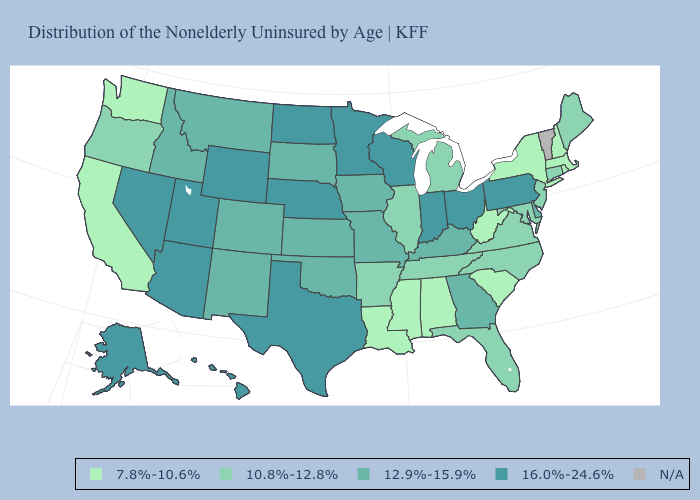Is the legend a continuous bar?
Keep it brief. No. Name the states that have a value in the range 10.8%-12.8%?
Answer briefly. Arkansas, Connecticut, Florida, Illinois, Maine, Maryland, Michigan, New Jersey, North Carolina, Oregon, Tennessee, Virginia. Name the states that have a value in the range 7.8%-10.6%?
Write a very short answer. Alabama, California, Louisiana, Massachusetts, Mississippi, New Hampshire, New York, Rhode Island, South Carolina, Washington, West Virginia. Does Virginia have the lowest value in the South?
Be succinct. No. Name the states that have a value in the range 7.8%-10.6%?
Short answer required. Alabama, California, Louisiana, Massachusetts, Mississippi, New Hampshire, New York, Rhode Island, South Carolina, Washington, West Virginia. How many symbols are there in the legend?
Concise answer only. 5. Name the states that have a value in the range 12.9%-15.9%?
Be succinct. Colorado, Delaware, Georgia, Idaho, Iowa, Kansas, Kentucky, Missouri, Montana, New Mexico, Oklahoma, South Dakota. Which states hav the highest value in the West?
Give a very brief answer. Alaska, Arizona, Hawaii, Nevada, Utah, Wyoming. What is the value of California?
Write a very short answer. 7.8%-10.6%. Does Montana have the lowest value in the West?
Write a very short answer. No. Does Texas have the highest value in the South?
Be succinct. Yes. What is the value of Nevada?
Answer briefly. 16.0%-24.6%. What is the value of Idaho?
Quick response, please. 12.9%-15.9%. Does Mississippi have the lowest value in the South?
Be succinct. Yes. Name the states that have a value in the range 16.0%-24.6%?
Keep it brief. Alaska, Arizona, Hawaii, Indiana, Minnesota, Nebraska, Nevada, North Dakota, Ohio, Pennsylvania, Texas, Utah, Wisconsin, Wyoming. 